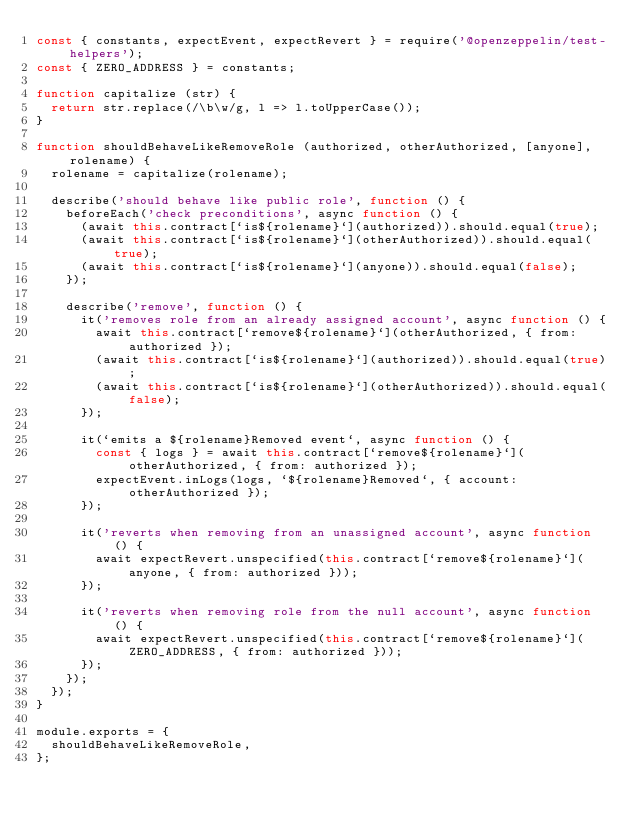<code> <loc_0><loc_0><loc_500><loc_500><_JavaScript_>const { constants, expectEvent, expectRevert } = require('@openzeppelin/test-helpers');
const { ZERO_ADDRESS } = constants;

function capitalize (str) {
  return str.replace(/\b\w/g, l => l.toUpperCase());
}

function shouldBehaveLikeRemoveRole (authorized, otherAuthorized, [anyone], rolename) {
  rolename = capitalize(rolename);

  describe('should behave like public role', function () {
    beforeEach('check preconditions', async function () {
      (await this.contract[`is${rolename}`](authorized)).should.equal(true);
      (await this.contract[`is${rolename}`](otherAuthorized)).should.equal(true);
      (await this.contract[`is${rolename}`](anyone)).should.equal(false);
    });

    describe('remove', function () {
      it('removes role from an already assigned account', async function () {
        await this.contract[`remove${rolename}`](otherAuthorized, { from: authorized });
        (await this.contract[`is${rolename}`](authorized)).should.equal(true);
        (await this.contract[`is${rolename}`](otherAuthorized)).should.equal(false);
      });

      it(`emits a ${rolename}Removed event`, async function () {
        const { logs } = await this.contract[`remove${rolename}`](otherAuthorized, { from: authorized });
        expectEvent.inLogs(logs, `${rolename}Removed`, { account: otherAuthorized });
      });

      it('reverts when removing from an unassigned account', async function () {
        await expectRevert.unspecified(this.contract[`remove${rolename}`](anyone, { from: authorized }));
      });

      it('reverts when removing role from the null account', async function () {
        await expectRevert.unspecified(this.contract[`remove${rolename}`](ZERO_ADDRESS, { from: authorized }));
      });
    });
  });
}

module.exports = {
  shouldBehaveLikeRemoveRole,
};
</code> 